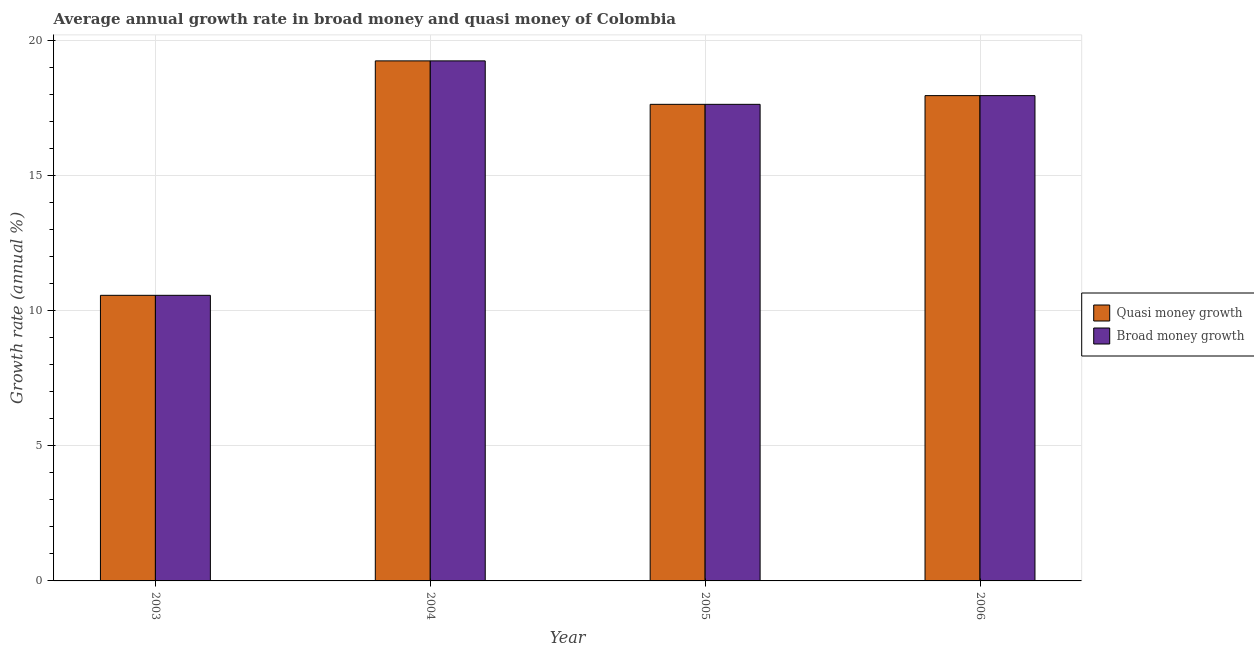How many different coloured bars are there?
Provide a succinct answer. 2. How many groups of bars are there?
Your answer should be very brief. 4. Are the number of bars per tick equal to the number of legend labels?
Offer a terse response. Yes. How many bars are there on the 1st tick from the left?
Give a very brief answer. 2. How many bars are there on the 4th tick from the right?
Give a very brief answer. 2. In how many cases, is the number of bars for a given year not equal to the number of legend labels?
Keep it short and to the point. 0. What is the annual growth rate in quasi money in 2005?
Offer a terse response. 17.63. Across all years, what is the maximum annual growth rate in broad money?
Give a very brief answer. 19.24. Across all years, what is the minimum annual growth rate in broad money?
Your answer should be compact. 10.57. In which year was the annual growth rate in quasi money maximum?
Offer a terse response. 2004. In which year was the annual growth rate in quasi money minimum?
Provide a short and direct response. 2003. What is the total annual growth rate in broad money in the graph?
Make the answer very short. 65.39. What is the difference between the annual growth rate in broad money in 2003 and that in 2004?
Your answer should be very brief. -8.67. What is the difference between the annual growth rate in quasi money in 2005 and the annual growth rate in broad money in 2006?
Your answer should be compact. -0.32. What is the average annual growth rate in quasi money per year?
Your response must be concise. 16.35. In how many years, is the annual growth rate in quasi money greater than 19 %?
Your answer should be compact. 1. What is the ratio of the annual growth rate in quasi money in 2005 to that in 2006?
Your answer should be very brief. 0.98. Is the difference between the annual growth rate in broad money in 2003 and 2004 greater than the difference between the annual growth rate in quasi money in 2003 and 2004?
Your response must be concise. No. What is the difference between the highest and the second highest annual growth rate in broad money?
Provide a succinct answer. 1.29. What is the difference between the highest and the lowest annual growth rate in quasi money?
Provide a short and direct response. 8.67. What does the 1st bar from the left in 2004 represents?
Your answer should be compact. Quasi money growth. What does the 1st bar from the right in 2006 represents?
Your answer should be very brief. Broad money growth. What is the difference between two consecutive major ticks on the Y-axis?
Your response must be concise. 5. Are the values on the major ticks of Y-axis written in scientific E-notation?
Give a very brief answer. No. Does the graph contain grids?
Provide a short and direct response. Yes. Where does the legend appear in the graph?
Your response must be concise. Center right. What is the title of the graph?
Make the answer very short. Average annual growth rate in broad money and quasi money of Colombia. Does "Attending school" appear as one of the legend labels in the graph?
Make the answer very short. No. What is the label or title of the X-axis?
Provide a succinct answer. Year. What is the label or title of the Y-axis?
Keep it short and to the point. Growth rate (annual %). What is the Growth rate (annual %) in Quasi money growth in 2003?
Provide a short and direct response. 10.57. What is the Growth rate (annual %) of Broad money growth in 2003?
Your answer should be compact. 10.57. What is the Growth rate (annual %) of Quasi money growth in 2004?
Provide a succinct answer. 19.24. What is the Growth rate (annual %) of Broad money growth in 2004?
Your answer should be compact. 19.24. What is the Growth rate (annual %) of Quasi money growth in 2005?
Offer a very short reply. 17.63. What is the Growth rate (annual %) in Broad money growth in 2005?
Offer a very short reply. 17.63. What is the Growth rate (annual %) in Quasi money growth in 2006?
Make the answer very short. 17.95. What is the Growth rate (annual %) in Broad money growth in 2006?
Your response must be concise. 17.95. Across all years, what is the maximum Growth rate (annual %) of Quasi money growth?
Your answer should be compact. 19.24. Across all years, what is the maximum Growth rate (annual %) of Broad money growth?
Your answer should be very brief. 19.24. Across all years, what is the minimum Growth rate (annual %) in Quasi money growth?
Provide a succinct answer. 10.57. Across all years, what is the minimum Growth rate (annual %) of Broad money growth?
Offer a very short reply. 10.57. What is the total Growth rate (annual %) in Quasi money growth in the graph?
Your answer should be very brief. 65.39. What is the total Growth rate (annual %) in Broad money growth in the graph?
Provide a succinct answer. 65.39. What is the difference between the Growth rate (annual %) of Quasi money growth in 2003 and that in 2004?
Offer a very short reply. -8.67. What is the difference between the Growth rate (annual %) of Broad money growth in 2003 and that in 2004?
Make the answer very short. -8.67. What is the difference between the Growth rate (annual %) of Quasi money growth in 2003 and that in 2005?
Give a very brief answer. -7.07. What is the difference between the Growth rate (annual %) of Broad money growth in 2003 and that in 2005?
Provide a succinct answer. -7.07. What is the difference between the Growth rate (annual %) in Quasi money growth in 2003 and that in 2006?
Your response must be concise. -7.39. What is the difference between the Growth rate (annual %) of Broad money growth in 2003 and that in 2006?
Your answer should be compact. -7.39. What is the difference between the Growth rate (annual %) in Quasi money growth in 2004 and that in 2005?
Offer a very short reply. 1.61. What is the difference between the Growth rate (annual %) of Broad money growth in 2004 and that in 2005?
Provide a short and direct response. 1.61. What is the difference between the Growth rate (annual %) of Quasi money growth in 2004 and that in 2006?
Your response must be concise. 1.29. What is the difference between the Growth rate (annual %) of Broad money growth in 2004 and that in 2006?
Offer a terse response. 1.29. What is the difference between the Growth rate (annual %) in Quasi money growth in 2005 and that in 2006?
Ensure brevity in your answer.  -0.32. What is the difference between the Growth rate (annual %) of Broad money growth in 2005 and that in 2006?
Offer a very short reply. -0.32. What is the difference between the Growth rate (annual %) in Quasi money growth in 2003 and the Growth rate (annual %) in Broad money growth in 2004?
Provide a short and direct response. -8.67. What is the difference between the Growth rate (annual %) of Quasi money growth in 2003 and the Growth rate (annual %) of Broad money growth in 2005?
Give a very brief answer. -7.07. What is the difference between the Growth rate (annual %) in Quasi money growth in 2003 and the Growth rate (annual %) in Broad money growth in 2006?
Ensure brevity in your answer.  -7.39. What is the difference between the Growth rate (annual %) of Quasi money growth in 2004 and the Growth rate (annual %) of Broad money growth in 2005?
Offer a terse response. 1.61. What is the difference between the Growth rate (annual %) in Quasi money growth in 2004 and the Growth rate (annual %) in Broad money growth in 2006?
Give a very brief answer. 1.29. What is the difference between the Growth rate (annual %) of Quasi money growth in 2005 and the Growth rate (annual %) of Broad money growth in 2006?
Your answer should be compact. -0.32. What is the average Growth rate (annual %) in Quasi money growth per year?
Your answer should be compact. 16.35. What is the average Growth rate (annual %) in Broad money growth per year?
Offer a very short reply. 16.35. In the year 2005, what is the difference between the Growth rate (annual %) of Quasi money growth and Growth rate (annual %) of Broad money growth?
Make the answer very short. 0. What is the ratio of the Growth rate (annual %) of Quasi money growth in 2003 to that in 2004?
Ensure brevity in your answer.  0.55. What is the ratio of the Growth rate (annual %) of Broad money growth in 2003 to that in 2004?
Offer a very short reply. 0.55. What is the ratio of the Growth rate (annual %) in Quasi money growth in 2003 to that in 2005?
Make the answer very short. 0.6. What is the ratio of the Growth rate (annual %) of Broad money growth in 2003 to that in 2005?
Offer a terse response. 0.6. What is the ratio of the Growth rate (annual %) in Quasi money growth in 2003 to that in 2006?
Provide a succinct answer. 0.59. What is the ratio of the Growth rate (annual %) of Broad money growth in 2003 to that in 2006?
Make the answer very short. 0.59. What is the ratio of the Growth rate (annual %) in Quasi money growth in 2004 to that in 2005?
Your answer should be compact. 1.09. What is the ratio of the Growth rate (annual %) in Broad money growth in 2004 to that in 2005?
Ensure brevity in your answer.  1.09. What is the ratio of the Growth rate (annual %) in Quasi money growth in 2004 to that in 2006?
Your response must be concise. 1.07. What is the ratio of the Growth rate (annual %) of Broad money growth in 2004 to that in 2006?
Ensure brevity in your answer.  1.07. What is the ratio of the Growth rate (annual %) of Quasi money growth in 2005 to that in 2006?
Offer a very short reply. 0.98. What is the difference between the highest and the second highest Growth rate (annual %) in Quasi money growth?
Ensure brevity in your answer.  1.29. What is the difference between the highest and the second highest Growth rate (annual %) of Broad money growth?
Your answer should be very brief. 1.29. What is the difference between the highest and the lowest Growth rate (annual %) in Quasi money growth?
Offer a very short reply. 8.67. What is the difference between the highest and the lowest Growth rate (annual %) in Broad money growth?
Your answer should be compact. 8.67. 